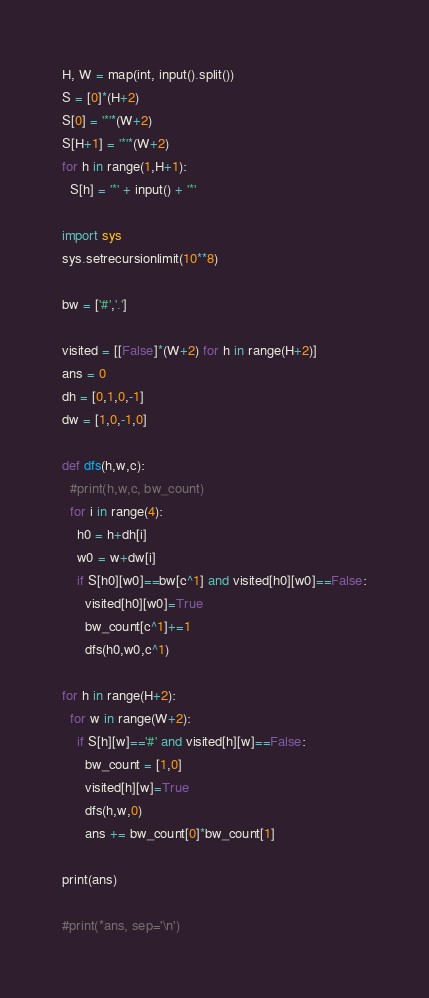Convert code to text. <code><loc_0><loc_0><loc_500><loc_500><_Python_>H, W = map(int, input().split())
S = [0]*(H+2)
S[0] = '*'*(W+2)
S[H+1] = '*'*(W+2)
for h in range(1,H+1):
  S[h] = '*' + input() + '*'

import sys
sys.setrecursionlimit(10**8)

bw = ['#','.']

visited = [[False]*(W+2) for h in range(H+2)]
ans = 0
dh = [0,1,0,-1]
dw = [1,0,-1,0]

def dfs(h,w,c):
  #print(h,w,c, bw_count)
  for i in range(4):
    h0 = h+dh[i]
    w0 = w+dw[i]
    if S[h0][w0]==bw[c^1] and visited[h0][w0]==False:
      visited[h0][w0]=True
      bw_count[c^1]+=1
      dfs(h0,w0,c^1)
  
for h in range(H+2):
  for w in range(W+2):
    if S[h][w]=='#' and visited[h][w]==False:
      bw_count = [1,0]
      visited[h][w]=True
      dfs(h,w,0)
      ans += bw_count[0]*bw_count[1]

print(ans)   

#print(*ans, sep='\n')
</code> 